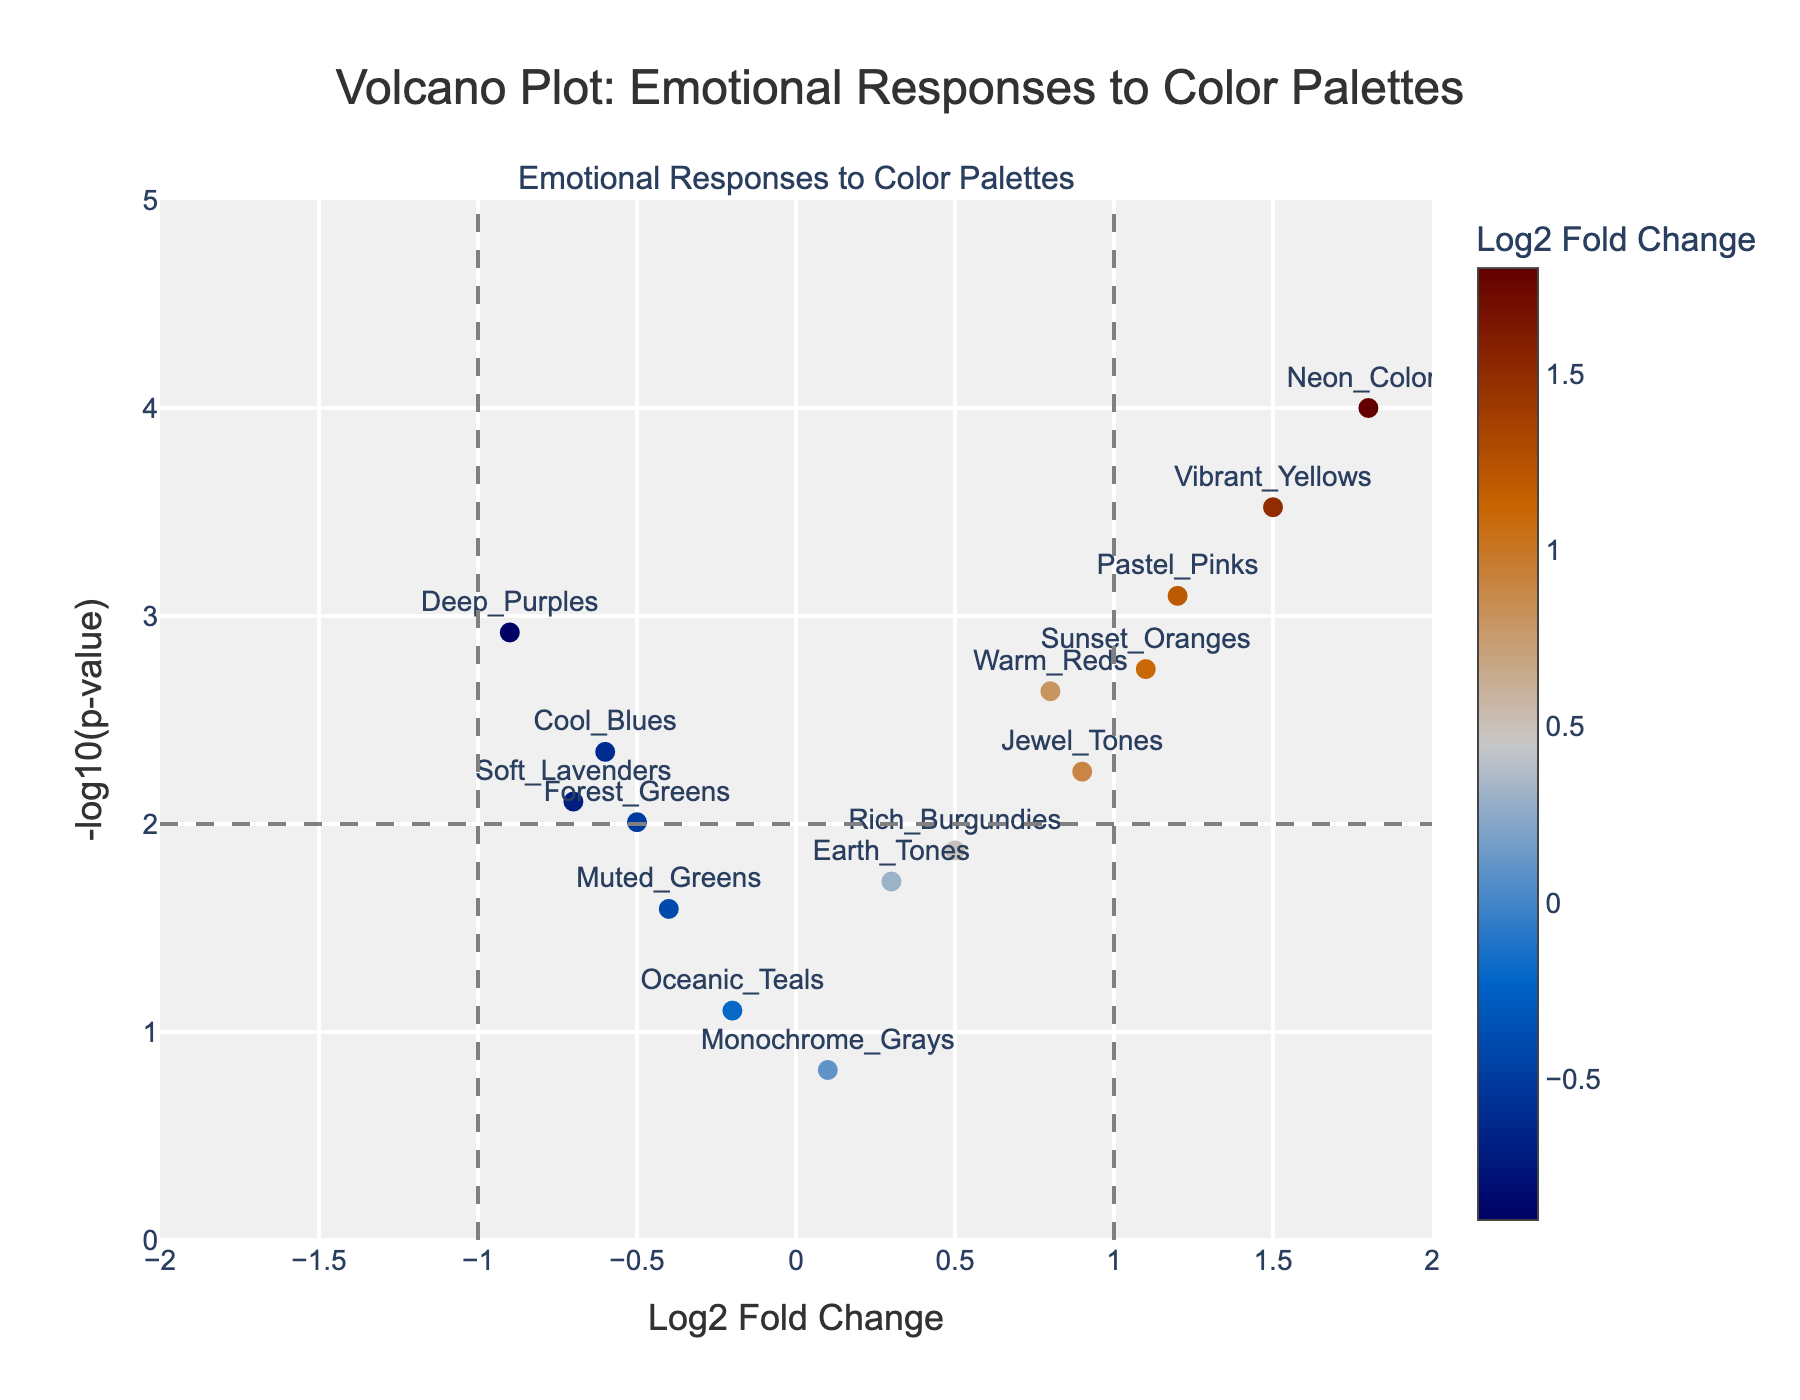What is the title of the plot? The title of the plot is displayed at the top of the figure. From the provided code and context, the title reads "Volcano Plot: Emotional Responses to Color Palettes".
Answer: Volcano Plot: Emotional Responses to Color Palettes How many color palettes have a significant emotional response based on their p-value? A color palette is considered significant if its p-value is below 0.05. In the plot, this can be identified by checking which points are above the significance threshold line at y = -log10(0.05), which corresponds to roughly y = 1.301. Count the number of points above this line.
Answer: 13 Which color palette has the highest log2 fold change? Find the point with the highest x-coordinate (log2 fold change) on the plot. According to the data, this corresponds to "Neon_Colors".
Answer: Neon_Colors What is the log2 fold change and p-value for Pastel Pinks? Look for the label "Pastel_Pinks" on the plot and read its x and y coordinates. According to the data, the log2 fold change is 1.2, and the p-value is 0.0008. Note that the p-value may not be directly visible, but you can calculate it from the y-axis value with 10^-y.
Answer: Log2 Fold Change: 1.2, p-value: 0.0008 How many color palettes have a negative log2 fold change? Count the number of points that are to the left of the zero line (negative x-values). In this plot, such color palettes include "Cool_Blues", "Deep_Purples", "Muted_Greens", "Soft_Lavenders", "Forest_Greens", and "Oceanic_Teals".
Answer: 6 Which color palettes have a more significant emotional response than "Rich Burgundies"? Rich Burgundies have a significance value represented by the height on the y-axis (-log10(p-value)). Identify the points with higher y-values than the one labeled "Rich_Burgundies".
Answer: Warm_Reds, Cool_Blues, Pastel_Pinks, Deep_Purples, Vibrant_Yellows, Neon_Colors, Sunset_Oranges, Soft_Lavenders Which color palette has the lowest p-value? The lowest p-value corresponds to the highest point on the y-axis (-log10(p-value)). According to the data, "Neon_Colors" has the lowest p-value.
Answer: Neon_Colors Compare the emotional response significance between "Warm_Reds" and "Cool_Blues". Locate the points for "Warm_Reds" and "Cool_Blues" on the plot. Compare their y-values. Higher y-value means a more significant response. According to the data, "Warm_Reds" has a y-value of roughly -log10(0.0023) = 2.64, and "Cool_Blues" has a y-value of roughly -log10(0.0045) = 2.35.
Answer: Warm_Reds have a more significant response than Cool_Blues 